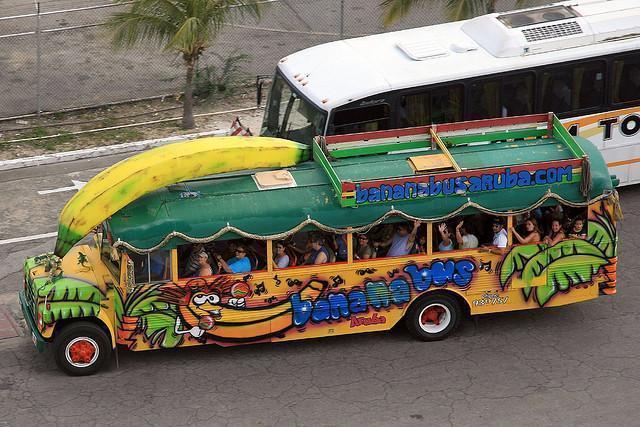Which one of these is a sister island to this location?
Pick the right solution, then justify: 'Answer: answer
Rationale: rationale.'
Options: Jamaica, bonaire, barbados, cuba. Answer: bonaire.
Rationale: The island is bonaire. 